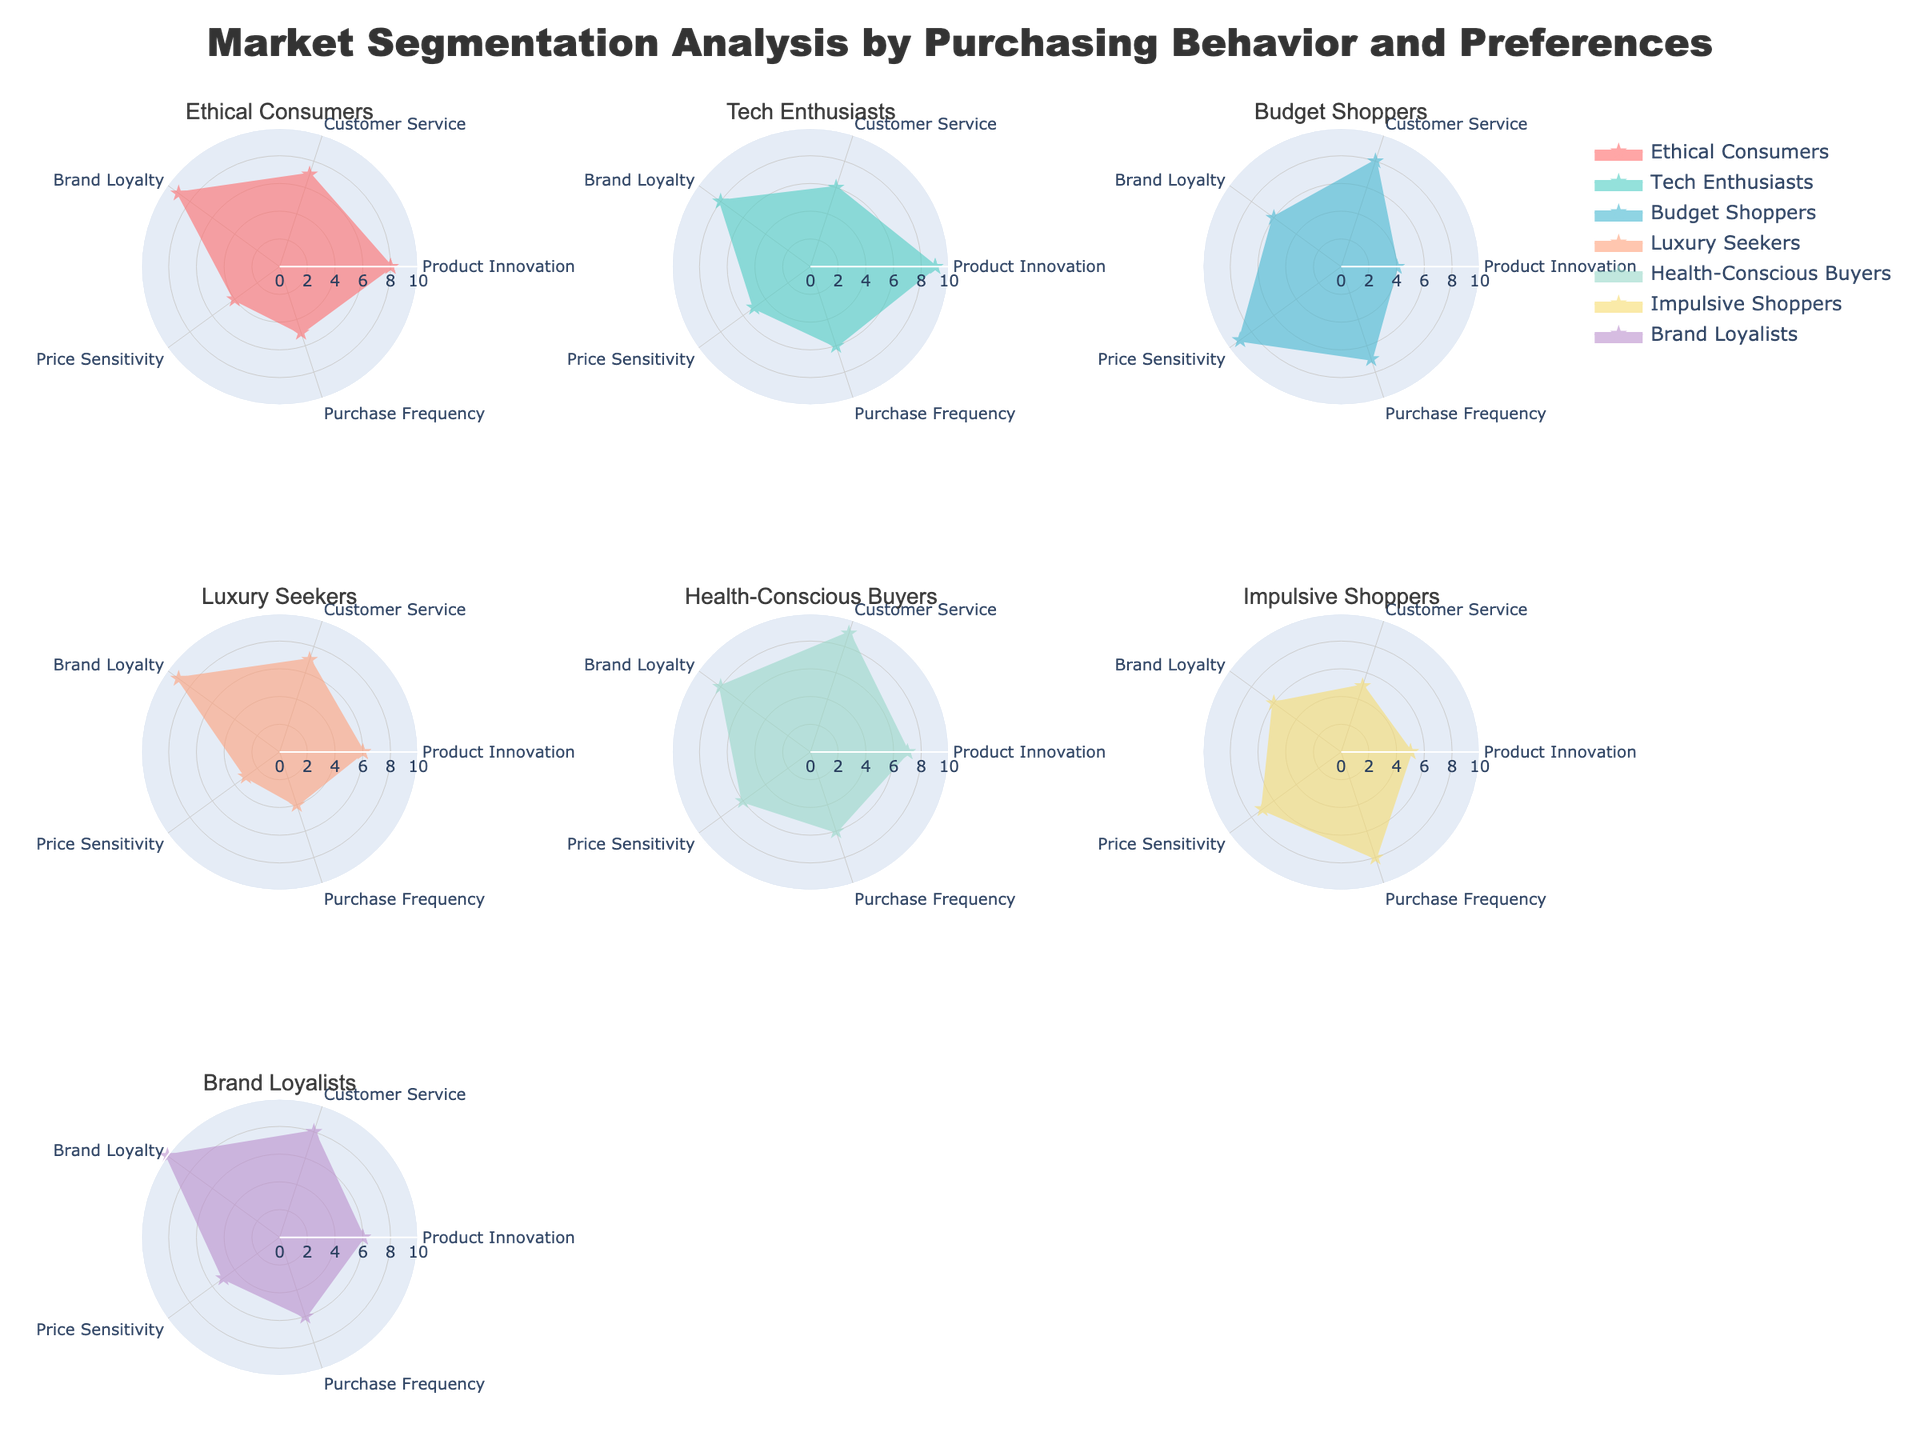What is the title of the figure? The title is usually placed at the top of the figure. The title for this figure is "Market Segmentation Analysis by Purchasing Behavior and Preferences."
Answer: Market Segmentation Analysis by Purchasing Behavior and Preferences Which customer segment has the highest score for Brand Loyalty? By looking at the radar charts for each segment, the one with the highest value for Brand Loyalty can be identified. Brand Loyalty is indicated by the 'Brand Loyalty' axis. The "Brand Loyalists" segment has the highest Brand Loyalty score of 10.
Answer: Brand Loyalists How many customer segments have a Purchasing Frequency score of 6 or higher? Check each individual subplot for the 'Purchase Frequency' axis and count the segments with values 6 or higher. "Tech Enthusiasts," "Health-Conscious Buyers," "Impulsive Shoppers," and "Brand Loyalists" have scores of 6 or higher for Purchase Frequency. That's 4 segments.
Answer: 4 Which customer segment is the most price-sensitive? Look for the segment with the highest score on the 'Price Sensitivity' axis. The "Budget Shoppers" segment has the highest Price Sensitivity score of 9.
Answer: Budget Shoppers Compare Product Innovation scores: Do Tech Enthusiasts have a higher score than Ethical Consumers? Check the 'Product Innovation' axis for both segments. "Tech Enthusiasts" have a score of 9, while "Ethical Consumers" have a score of 8. 9 is higher than 8.
Answer: Yes What's the average score for Customer Service across all segments? To find the average, sum the Customer Service scores for all segments and then divide by the number of segments. The scores are (7 + 6 + 8 + 7 + 9 + 5 + 8) = 50. There are 7 segments. 50/7 ≈ 7.14.
Answer: 7.14 Which customer segments are less sensitive to price than Ethical Consumers? Compare the 'Price Sensitivity' scores of all segments with that of "Ethical Consumers" (which is 4). Segments with lower scores are "Luxury Seekers" (3).
Answer: Luxury Seekers Between Health-Conscious Buyers and Impulsive Shoppers, which segment has a higher Purchase Frequency score? Check the 'Purchase Frequency' axis for both "Health-Conscious Buyers" and "Impulsive Shoppers." "Impulsive Shoppers" have a score of 8, while "Health-Conscious Buyers" have a score of 6. 8 is higher than 6.
Answer: Impulsive Shoppers What is the sum of the scores for Price Sensitivity for all segments? Add the 'Price Sensitivity' scores of all segments: (4 + 5 + 9 + 3 + 6 + 7 + 5) = 39.
Answer: 39 